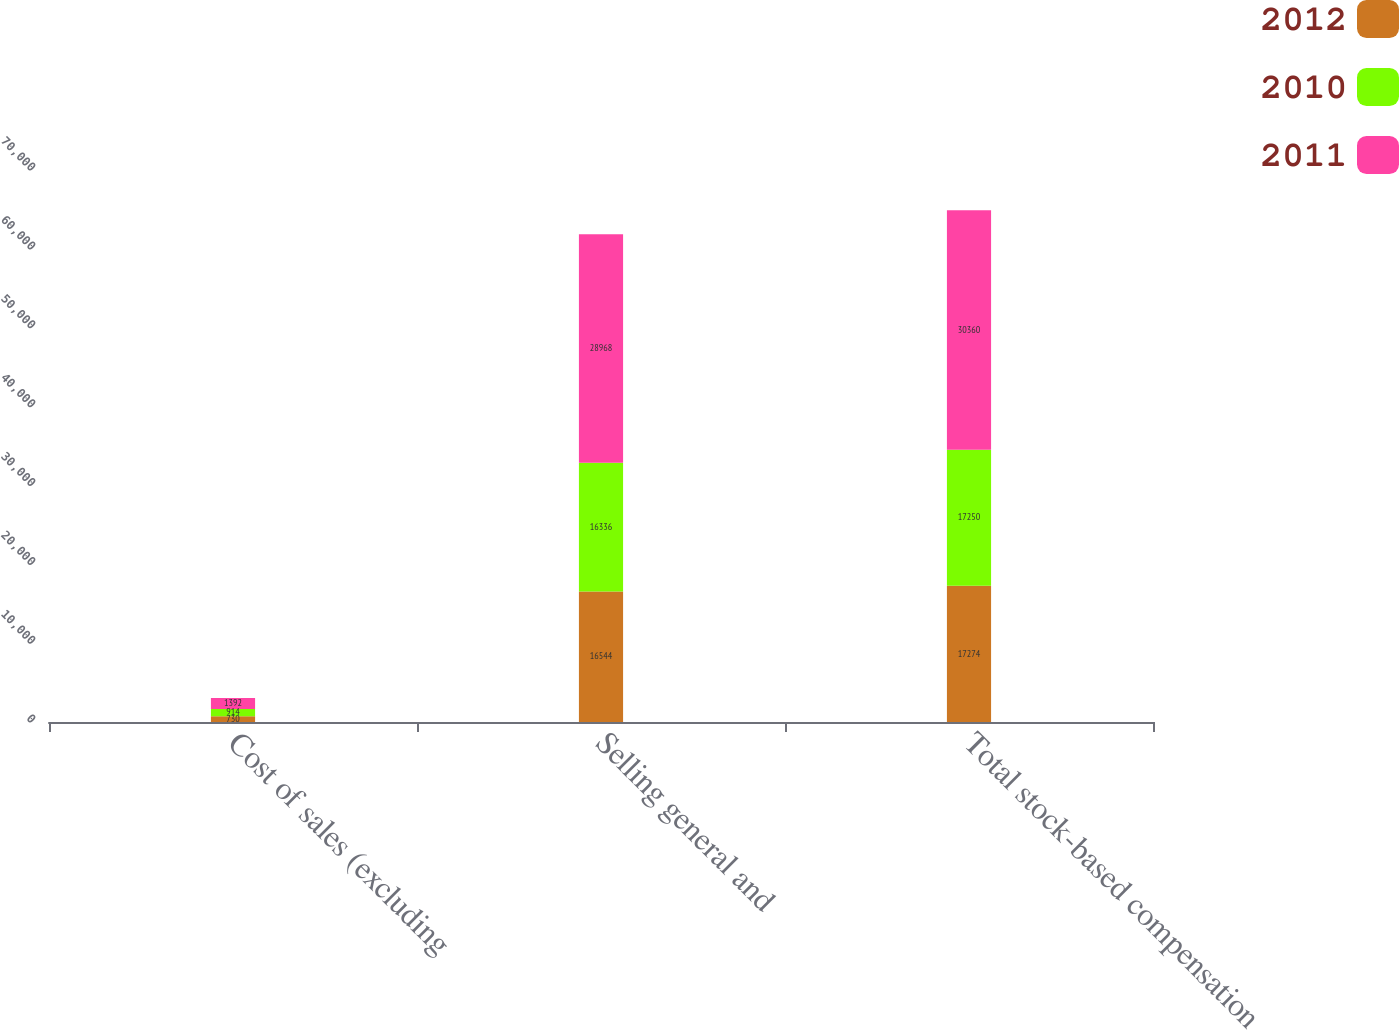Convert chart to OTSL. <chart><loc_0><loc_0><loc_500><loc_500><stacked_bar_chart><ecel><fcel>Cost of sales (excluding<fcel>Selling general and<fcel>Total stock-based compensation<nl><fcel>2012<fcel>730<fcel>16544<fcel>17274<nl><fcel>2010<fcel>914<fcel>16336<fcel>17250<nl><fcel>2011<fcel>1392<fcel>28968<fcel>30360<nl></chart> 